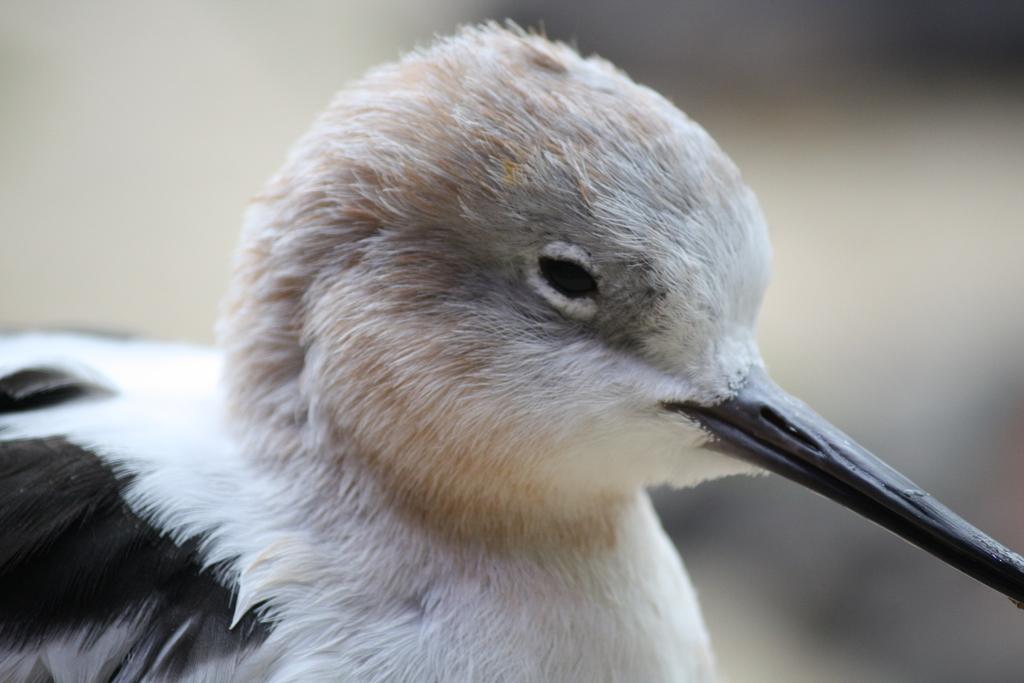Please provide a concise description of this image. In this picture we can see a bird. In the background of the image it is blurry. 